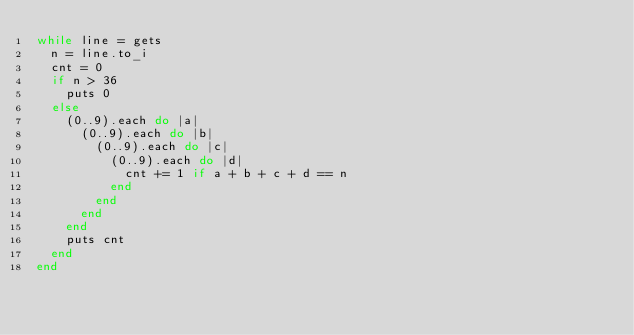Convert code to text. <code><loc_0><loc_0><loc_500><loc_500><_Ruby_>while line = gets
  n = line.to_i
  cnt = 0
  if n > 36
    puts 0
  else
    (0..9).each do |a|
      (0..9).each do |b|
        (0..9).each do |c|
          (0..9).each do |d|
            cnt += 1 if a + b + c + d == n
          end
        end
      end
    end
    puts cnt
  end
end</code> 